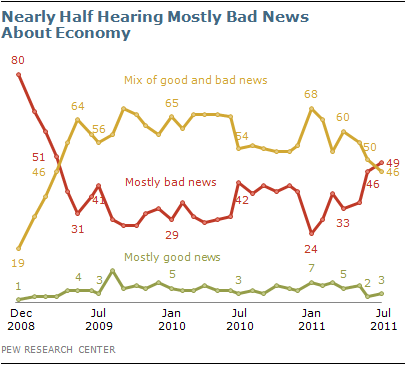List a handful of essential elements in this visual. The average of the minimum opinion percentages of the three scenarios is 14.67. The line graph with the least variations in its data is the green one. 